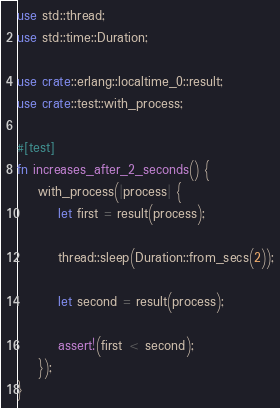Convert code to text. <code><loc_0><loc_0><loc_500><loc_500><_Rust_>use std::thread;
use std::time::Duration;

use crate::erlang::localtime_0::result;
use crate::test::with_process;

#[test]
fn increases_after_2_seconds() {
    with_process(|process| {
        let first = result(process);

        thread::sleep(Duration::from_secs(2));

        let second = result(process);

        assert!(first < second);
    });
}
</code> 